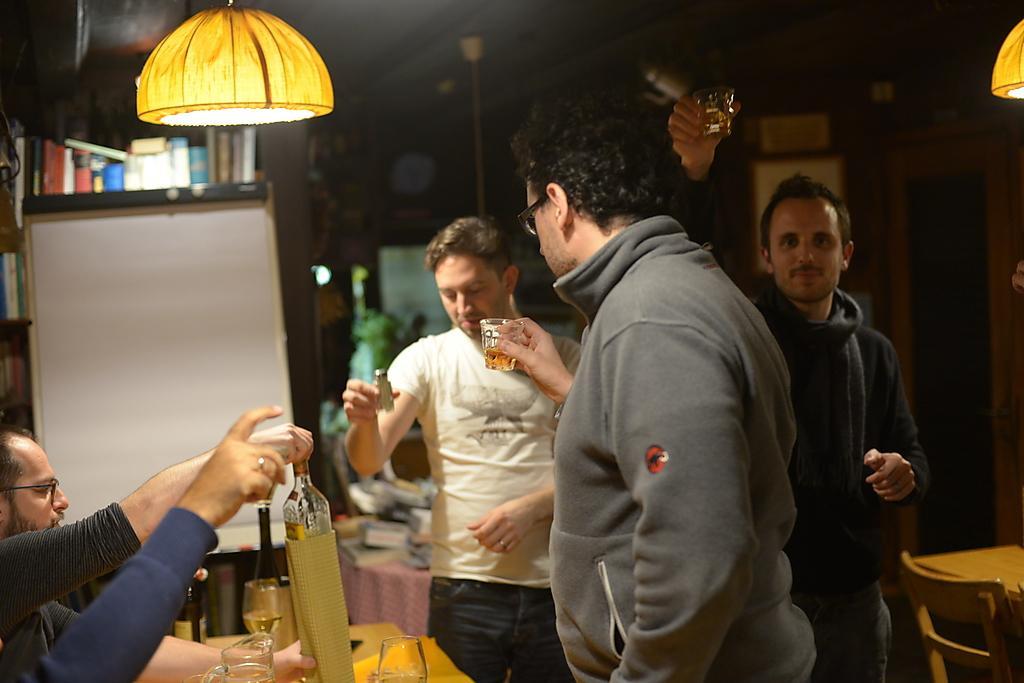In one or two sentences, can you explain what this image depicts? In this image there are few people. Three people are standing holding glasses. In the left side one person is sitting. in front of him there is a table. on the table there are bottles and glasses. on the top there are lights. In the right side there are table and chair. the background is not clear. Another hand is visible from left bottom corner. 